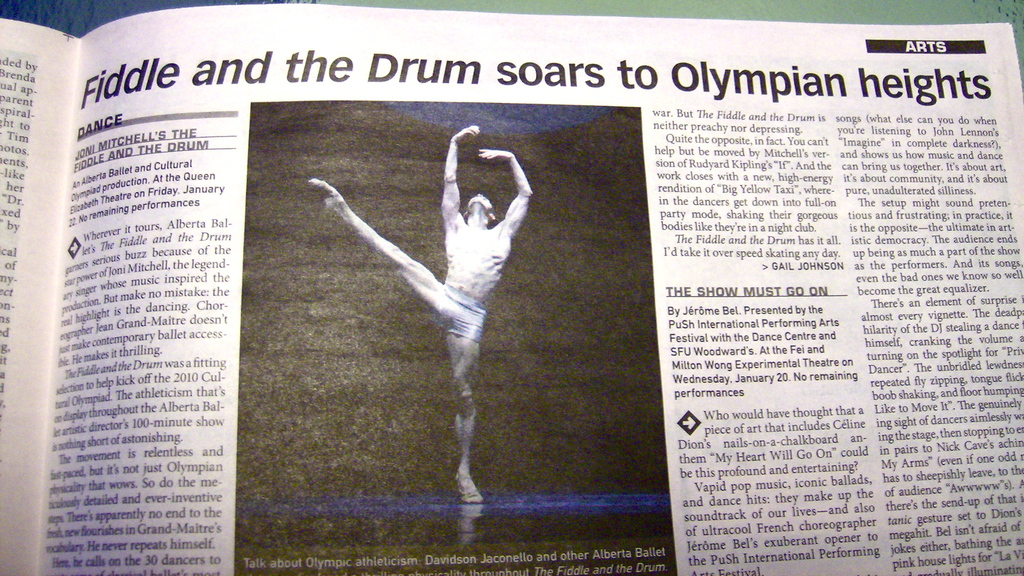What is the critical reception of the show as mentioned in the article? The show received high praise, described as 'fultracool' and 'exuberant', particularly noting the combination of contemporary ballet with powerful themes that significantly impact the audience. 